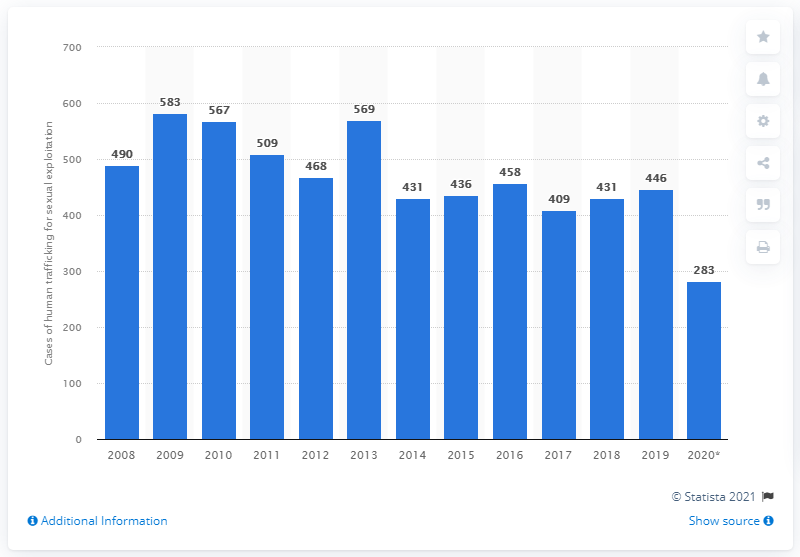How many sexual trafficking cases were registered in 2020?
 283 